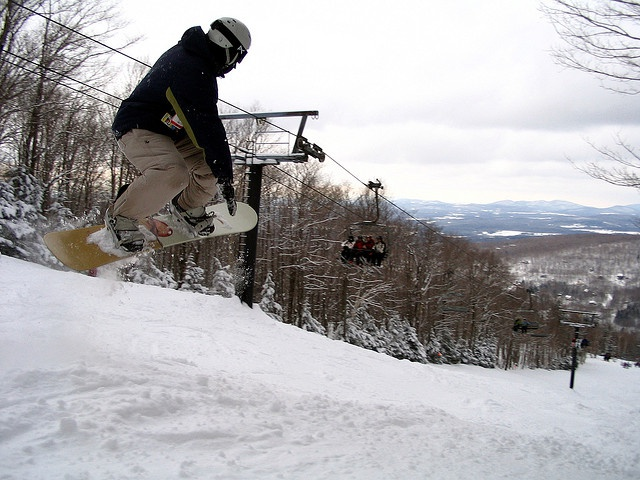Describe the objects in this image and their specific colors. I can see people in gray and black tones, snowboard in gray, darkgray, and olive tones, people in gray and black tones, people in gray, black, and maroon tones, and people in black, maroon, brown, and gray tones in this image. 